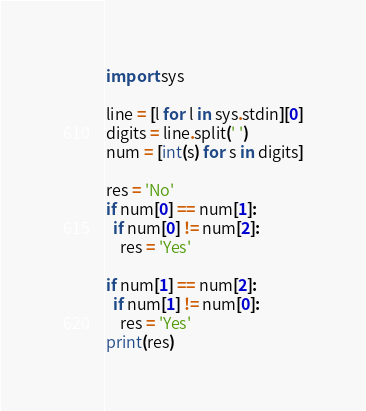<code> <loc_0><loc_0><loc_500><loc_500><_Python_>import sys
 
line = [l for l in sys.stdin][0]
digits = line.split(' ')
num = [int(s) for s in digits]
 
res = 'No'
if num[0] == num[1]:
  if num[0] != num[2]:
    res = 'Yes'
    
if num[1] == num[2]:
  if num[1] != num[0]:
    res = 'Yes'
print(res)</code> 